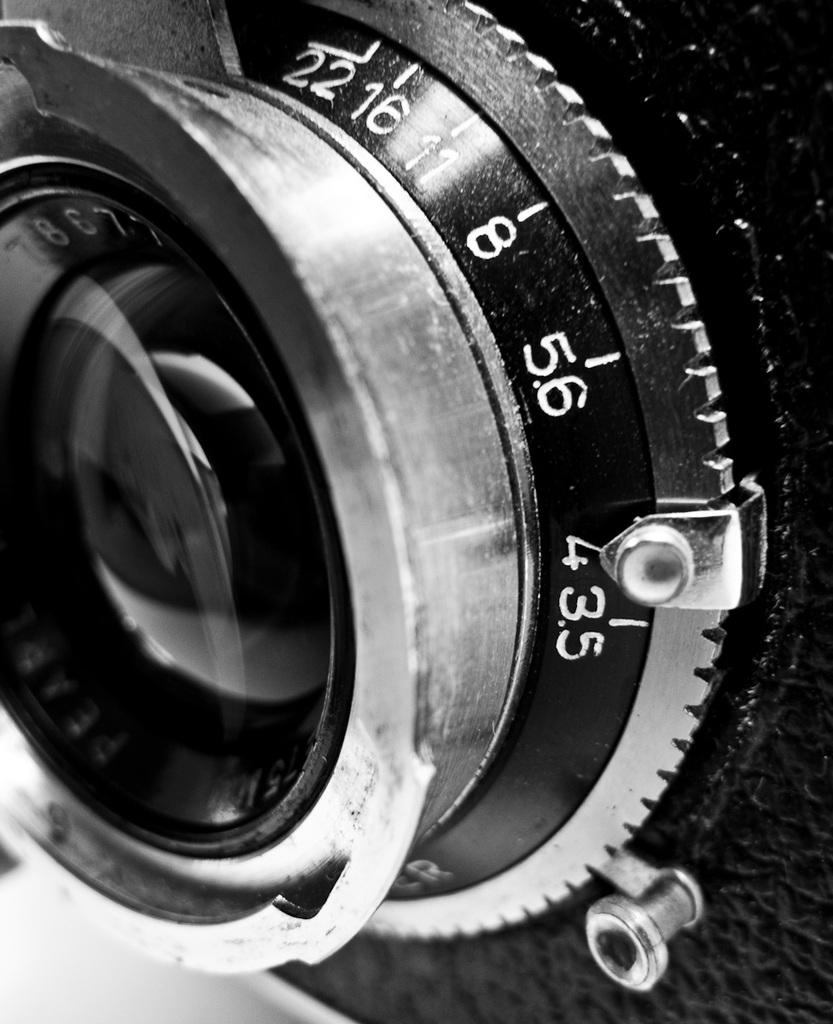What is the color scheme of the image? The image is black and white. What is the main subject of the image? There is a lens in the image. What other feature can be seen on the lens in the image? There is an aperture ring in the image. Can you tell me how many coils are present in the image? There are no coils present in the image; it features a lens with an aperture ring. What type of farm animals can be seen in the image? There are no farm animals present in the image; it features a lens with an aperture ring. 